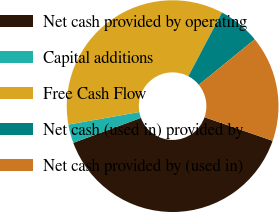Convert chart. <chart><loc_0><loc_0><loc_500><loc_500><pie_chart><fcel>Net cash provided by operating<fcel>Capital additions<fcel>Free Cash Flow<fcel>Net cash (used in) provided by<fcel>Net cash provided by (used in)<nl><fcel>39.06%<fcel>2.85%<fcel>35.51%<fcel>6.4%<fcel>16.18%<nl></chart> 